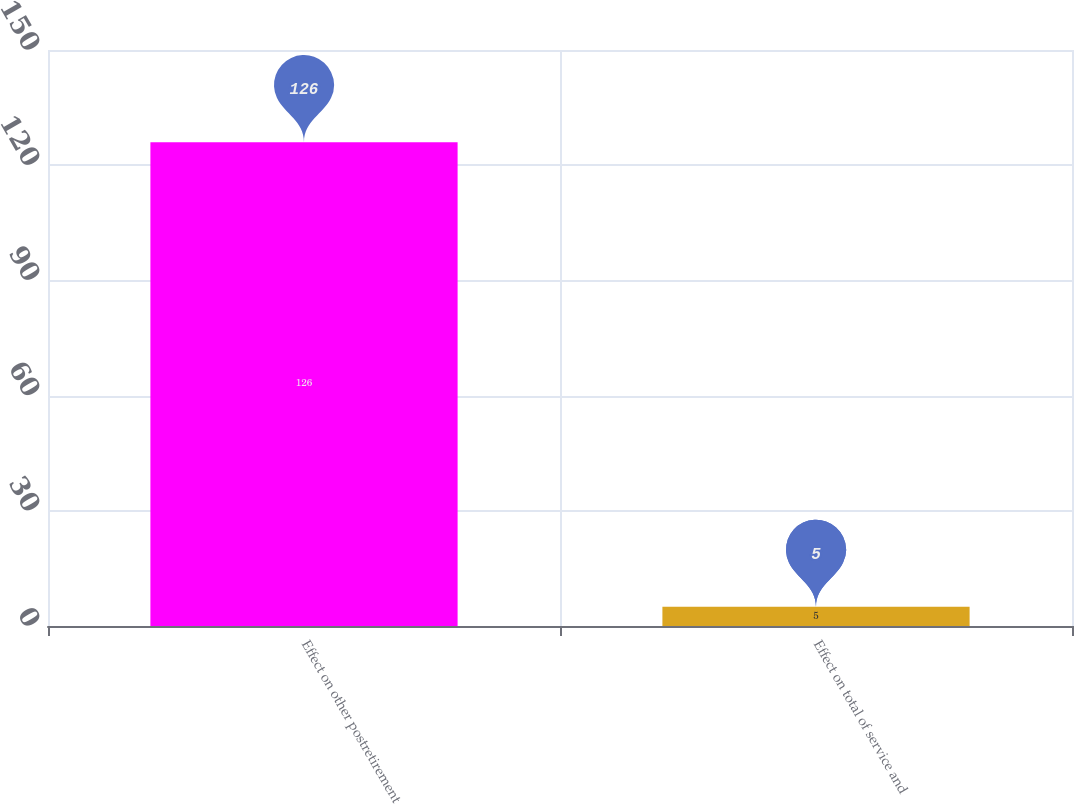Convert chart. <chart><loc_0><loc_0><loc_500><loc_500><bar_chart><fcel>Effect on other postretirement<fcel>Effect on total of service and<nl><fcel>126<fcel>5<nl></chart> 